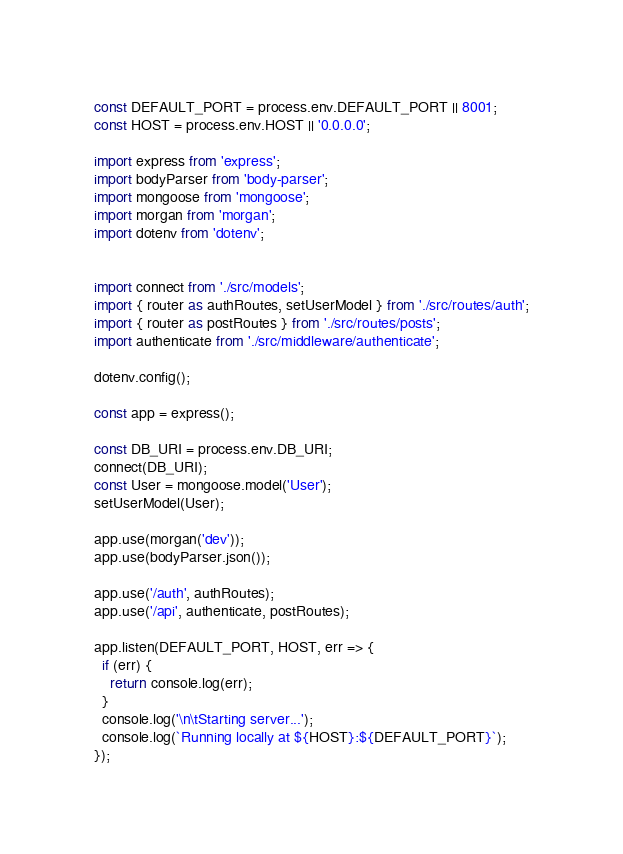<code> <loc_0><loc_0><loc_500><loc_500><_JavaScript_>const DEFAULT_PORT = process.env.DEFAULT_PORT || 8001;
const HOST = process.env.HOST || '0.0.0.0';

import express from 'express';
import bodyParser from 'body-parser';
import mongoose from 'mongoose';
import morgan from 'morgan';
import dotenv from 'dotenv';


import connect from './src/models';
import { router as authRoutes, setUserModel } from './src/routes/auth';
import { router as postRoutes } from './src/routes/posts';
import authenticate from './src/middleware/authenticate';

dotenv.config();

const app = express();

const DB_URI = process.env.DB_URI;
connect(DB_URI);
const User = mongoose.model('User');
setUserModel(User);

app.use(morgan('dev'));
app.use(bodyParser.json());

app.use('/auth', authRoutes);
app.use('/api', authenticate, postRoutes);

app.listen(DEFAULT_PORT, HOST, err => {
  if (err) {
    return console.log(err);
  }
  console.log('\n\tStarting server...');
  console.log(`Running locally at ${HOST}:${DEFAULT_PORT}`);
});
</code> 